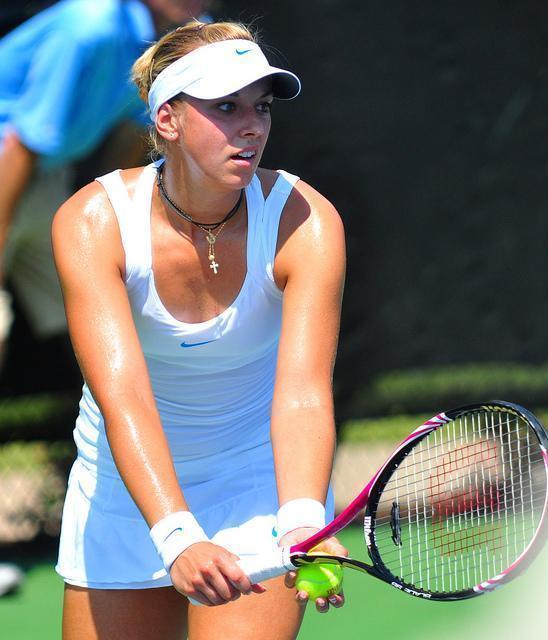When an athlete starts to overheat and sweat starts pouring there body is asking for what to replenish it?
Indicate the correct choice and explain in the format: 'Answer: answer
Rationale: rationale.'
Options: Sunscreen, coffee, soda, water. Answer: water.
Rationale: When someone sweats, the sweat is water leaving their body, so more water ingested is needed in order to replenish the body to its regular level. 